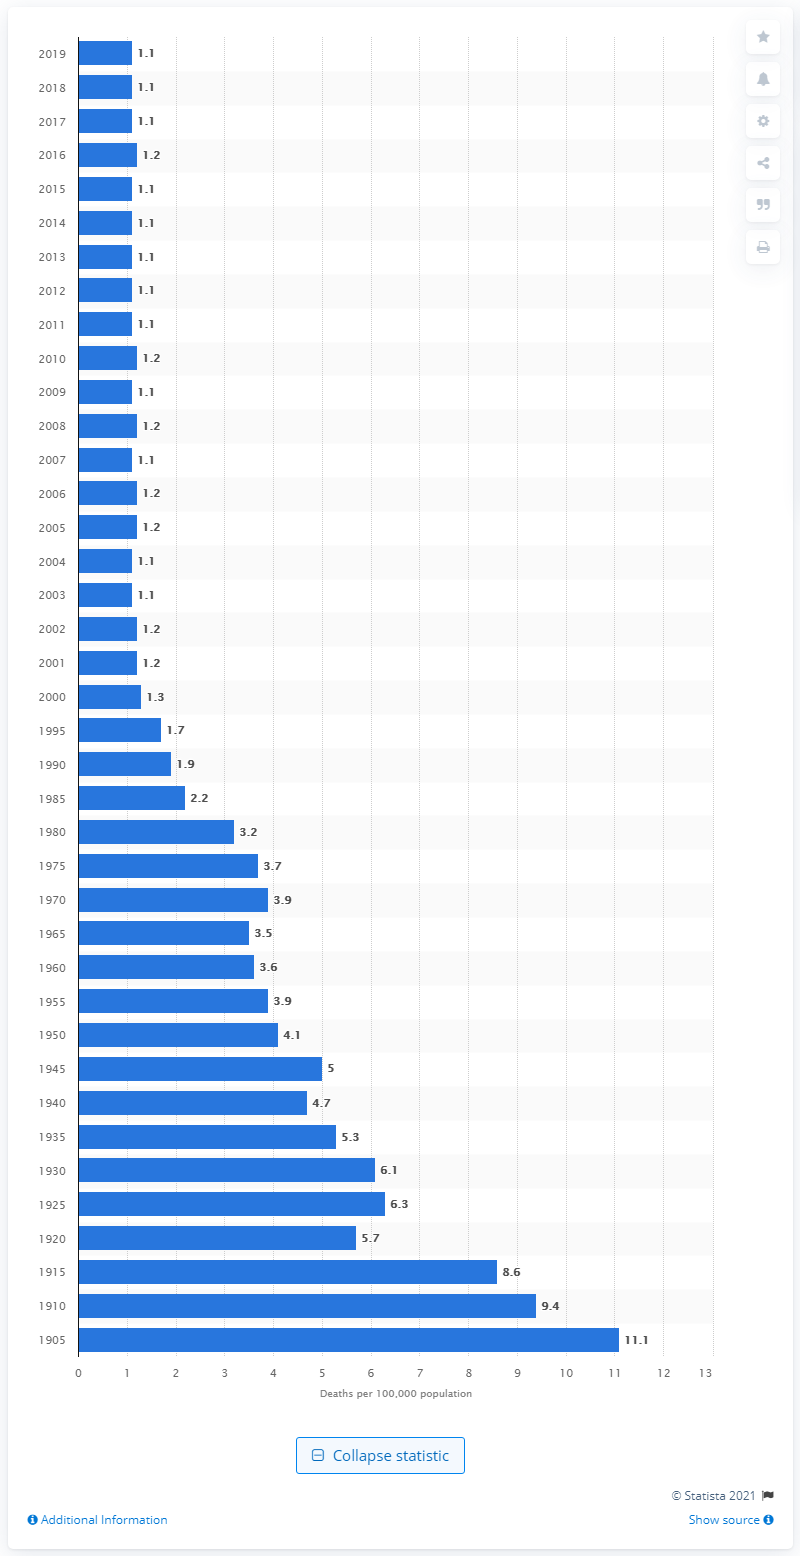Give some essential details in this illustration. In 1905, the highest rate of deaths due to drowning was 11.1 per 100,000 population in the United States. 